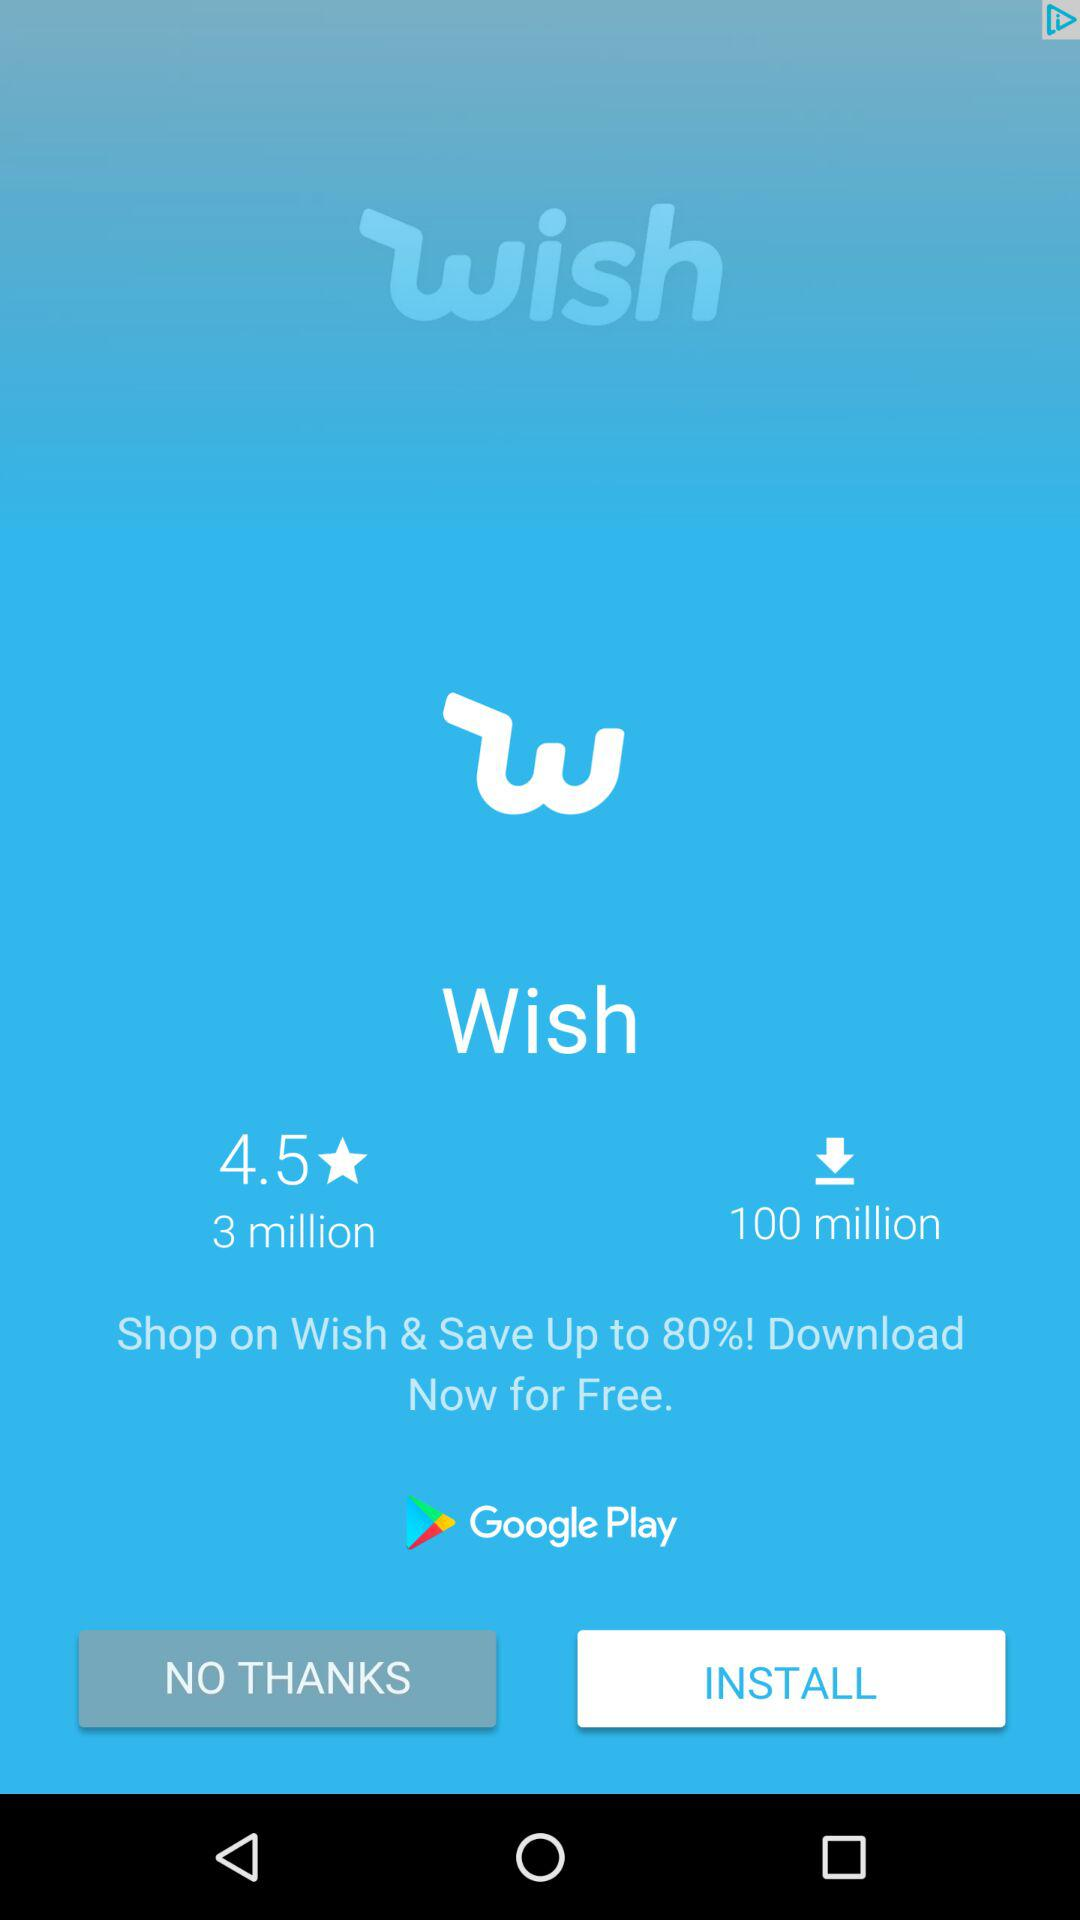How many more downloads does the app have than the number of reviews?
Answer the question using a single word or phrase. 97 million 